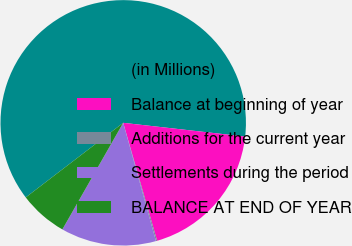<chart> <loc_0><loc_0><loc_500><loc_500><pie_chart><fcel>(in Millions)<fcel>Balance at beginning of year<fcel>Additions for the current year<fcel>Settlements during the period<fcel>BALANCE AT END OF YEAR<nl><fcel>62.18%<fcel>18.76%<fcel>0.15%<fcel>12.56%<fcel>6.35%<nl></chart> 